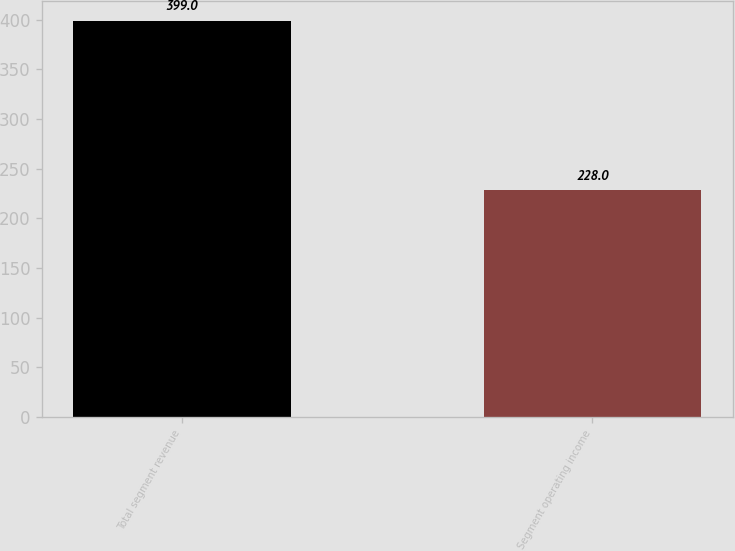Convert chart to OTSL. <chart><loc_0><loc_0><loc_500><loc_500><bar_chart><fcel>Total segment revenue<fcel>Segment operating income<nl><fcel>399<fcel>228<nl></chart> 